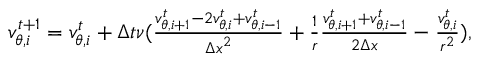<formula> <loc_0><loc_0><loc_500><loc_500>\begin{array} { r } { v _ { \theta , i } ^ { t + 1 } = v _ { \theta , i } ^ { t } + \Delta t \nu ( \frac { v _ { \theta , i + 1 } ^ { t } - 2 v _ { \theta , i } ^ { t } + v _ { \theta , i - 1 } ^ { t } } { { \Delta x } ^ { 2 } } + \frac { 1 } { r } \frac { v _ { \theta , i + 1 } ^ { t } + v _ { \theta , i - 1 } ^ { t } } { 2 \Delta x } - \frac { v _ { \theta , i } ^ { t } } { r ^ { 2 } } ) , } \end{array}</formula> 